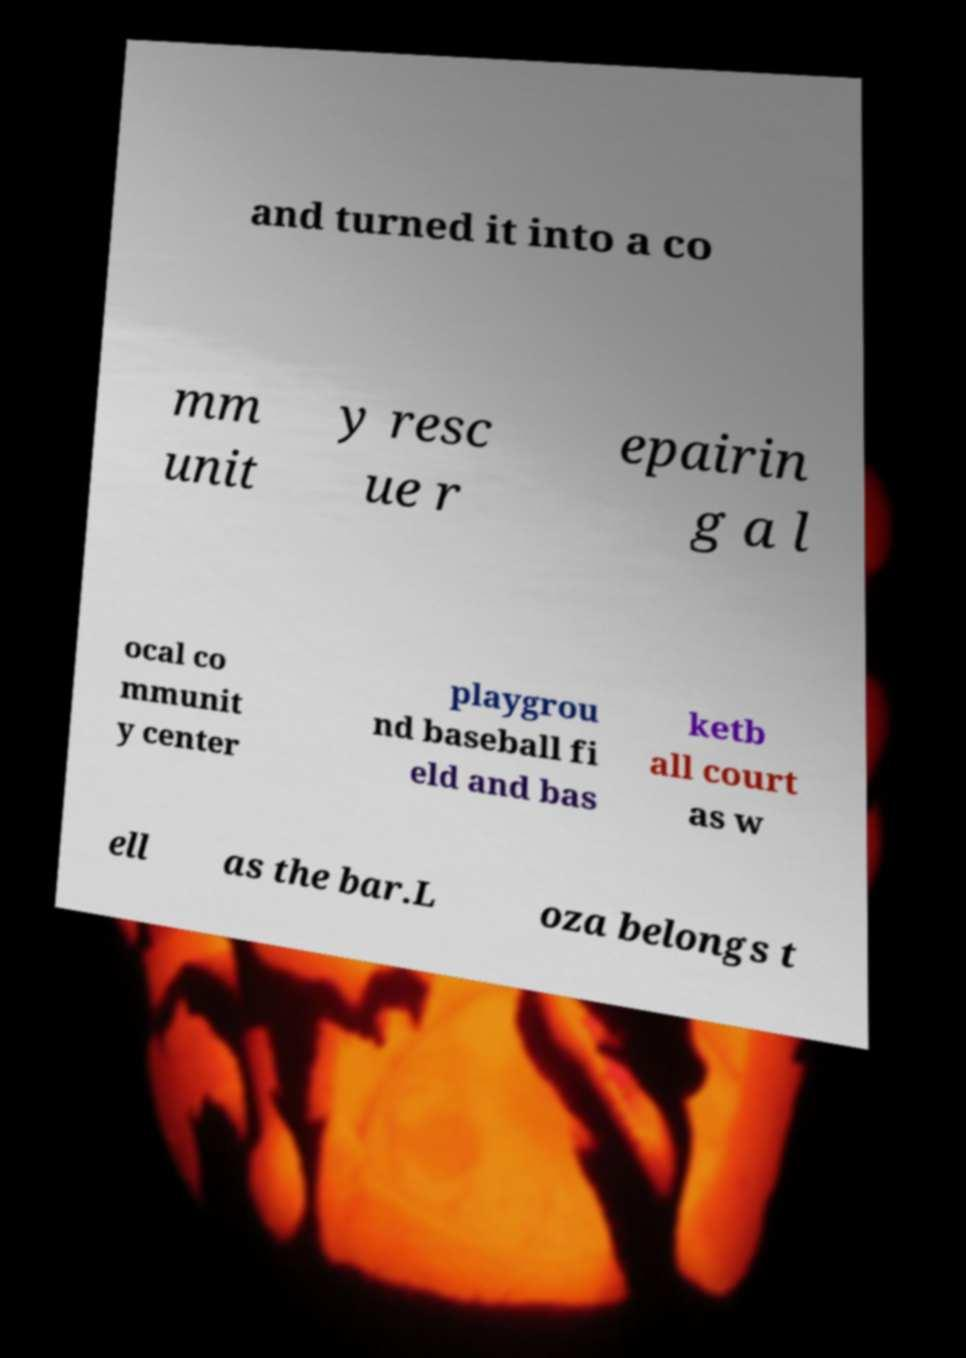Can you read and provide the text displayed in the image?This photo seems to have some interesting text. Can you extract and type it out for me? and turned it into a co mm unit y resc ue r epairin g a l ocal co mmunit y center playgrou nd baseball fi eld and bas ketb all court as w ell as the bar.L oza belongs t 